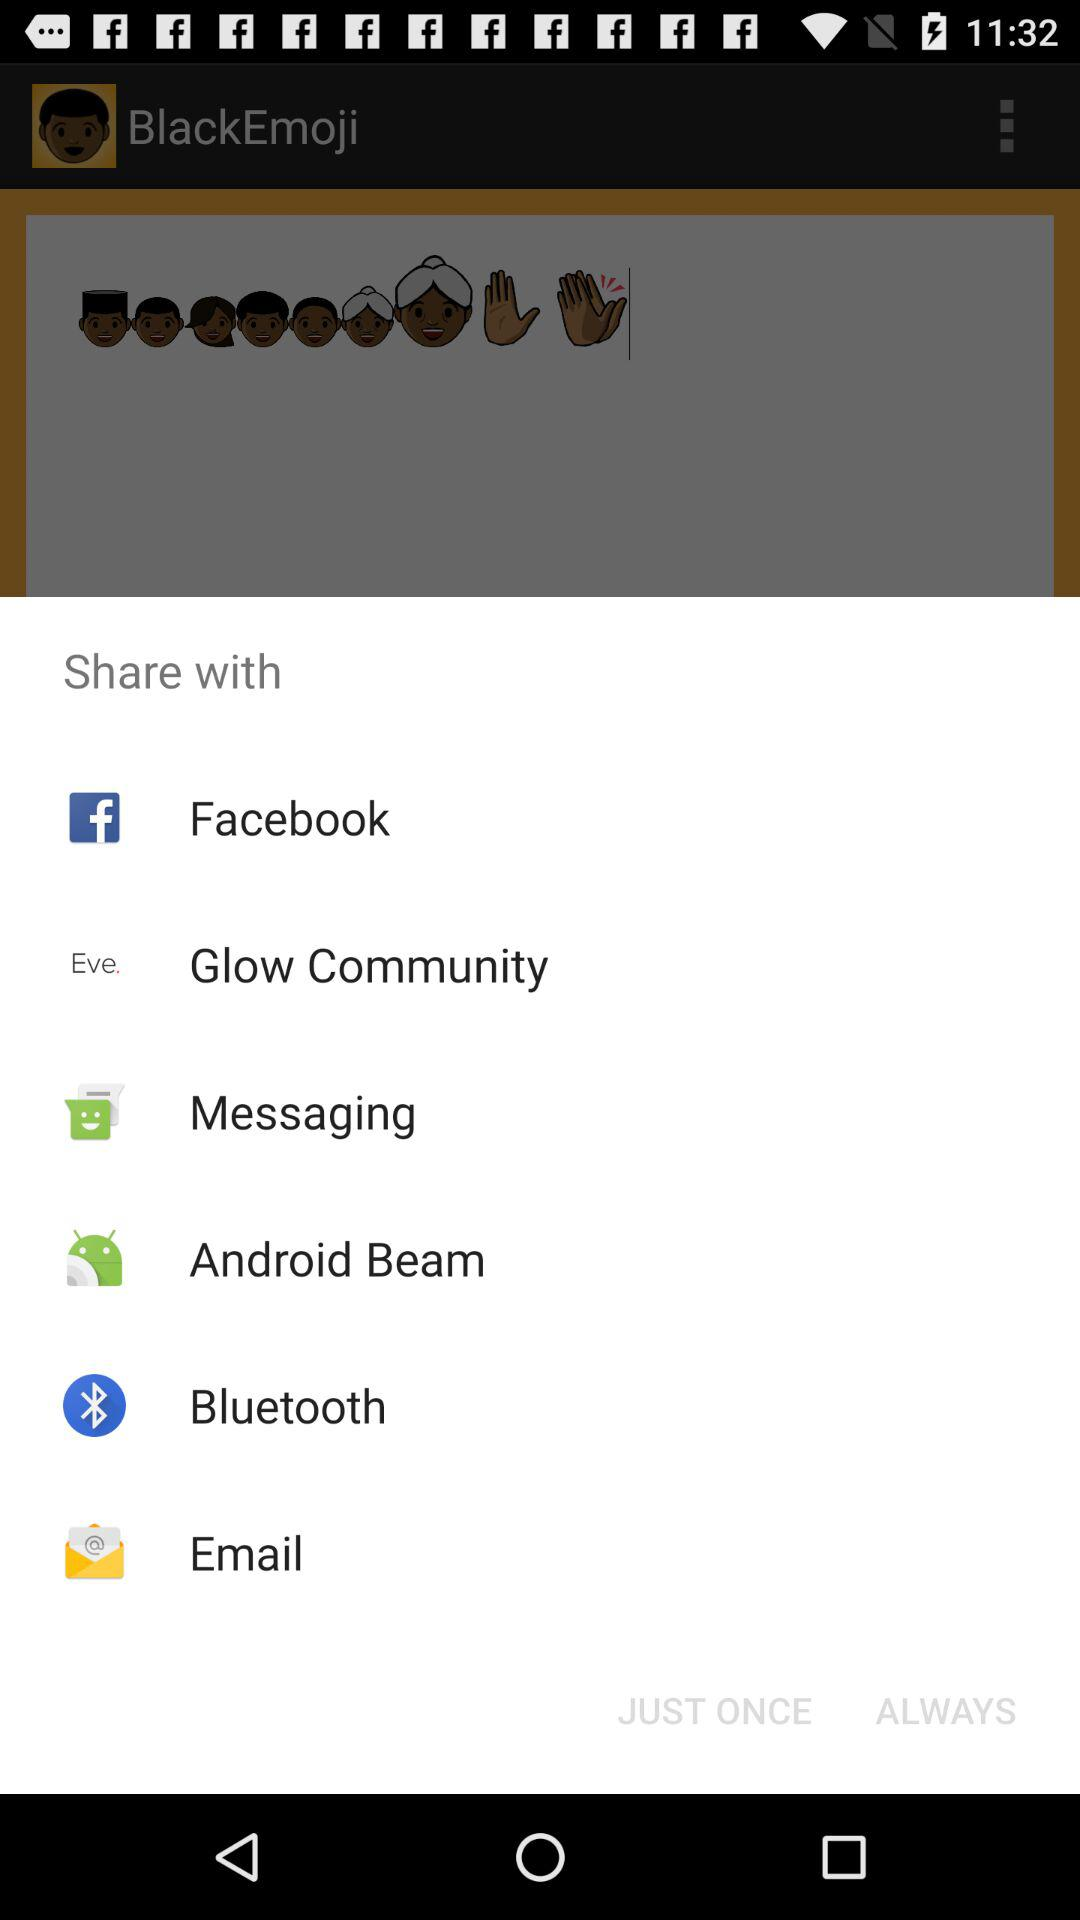Through which application can it be shared? The applications are "Facebook", "Glow Community", "Messaging", "Android Beam", "Bluetooth" and "Email". 